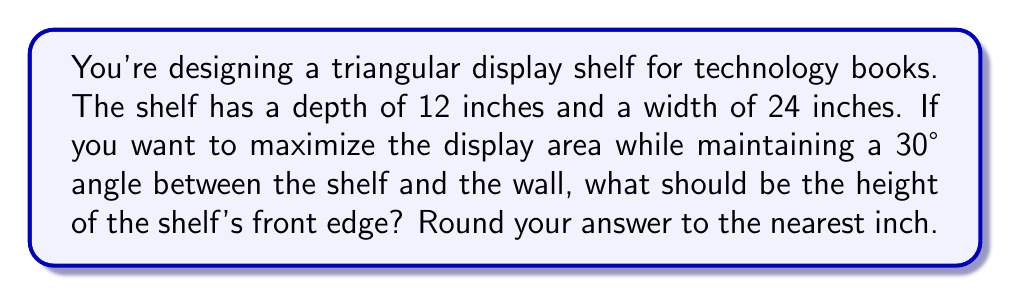Help me with this question. Let's approach this step-by-step:

1) We can visualize this as a right triangle, where:
   - The base is the depth of the shelf (12 inches)
   - The hypotenuse is the width of the shelf (24 inches)
   - The angle between the shelf and the wall is 30°
   - We need to find the height of the front edge

2) In a right triangle, we can use the sine function to find the height:

   $\sin(30°) = \frac{\text{height}}{\text{hypotenuse}}$

3) We know the hypotenuse is 24 inches, so we can set up the equation:

   $\sin(30°) = \frac{\text{height}}{24}$

4) Solve for height:

   $\text{height} = 24 \times \sin(30°)$

5) Calculate:
   $\sin(30°) = 0.5$
   
   $\text{height} = 24 \times 0.5 = 12$ inches

6) Therefore, the height of the shelf's front edge should be 12 inches.

7) We don't need to round as the result is already a whole number.

[asy]
import geometry;

size(200);
pair A=(0,0), B=(12,0), C=(0,12);
draw(A--B--C--A);
draw(rightanglemark(A,B,C,8));

label("12\"", (B--A)/2, S);
label("24\"", (C--A)/2, NW);
label("12\"", (B--C)/2, NE);
label("30°", A, SW);
[/asy]
Answer: 12 inches 